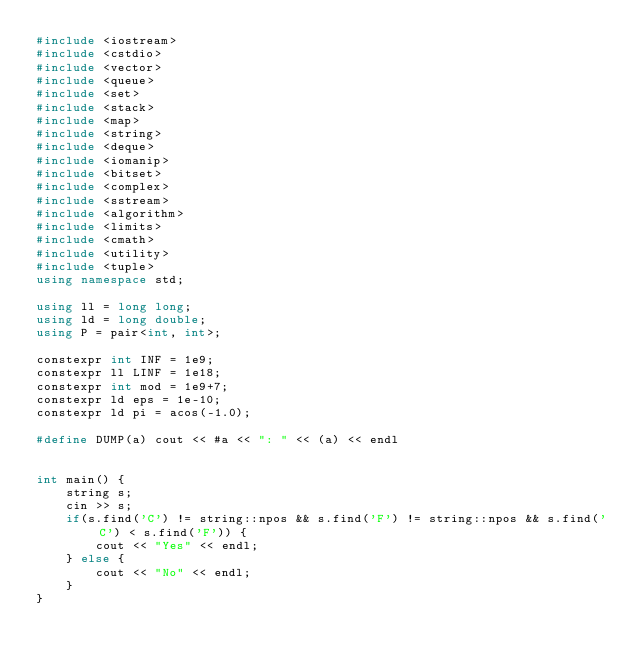<code> <loc_0><loc_0><loc_500><loc_500><_C++_>#include <iostream>
#include <cstdio>
#include <vector>
#include <queue>
#include <set>
#include <stack>
#include <map>
#include <string>
#include <deque>
#include <iomanip>
#include <bitset>
#include <complex>
#include <sstream>
#include <algorithm>
#include <limits>
#include <cmath>
#include <utility>
#include <tuple>
using namespace std;

using ll = long long;
using ld = long double;
using P = pair<int, int>;

constexpr int INF = 1e9;
constexpr ll LINF = 1e18;
constexpr int mod = 1e9+7;
constexpr ld eps = 1e-10;
constexpr ld pi = acos(-1.0);

#define DUMP(a) cout << #a << ": " << (a) << endl


int main() {
    string s;
    cin >> s;
    if(s.find('C') != string::npos && s.find('F') != string::npos && s.find('C') < s.find('F')) {
        cout << "Yes" << endl;
    } else {
        cout << "No" << endl;
    }
}

</code> 